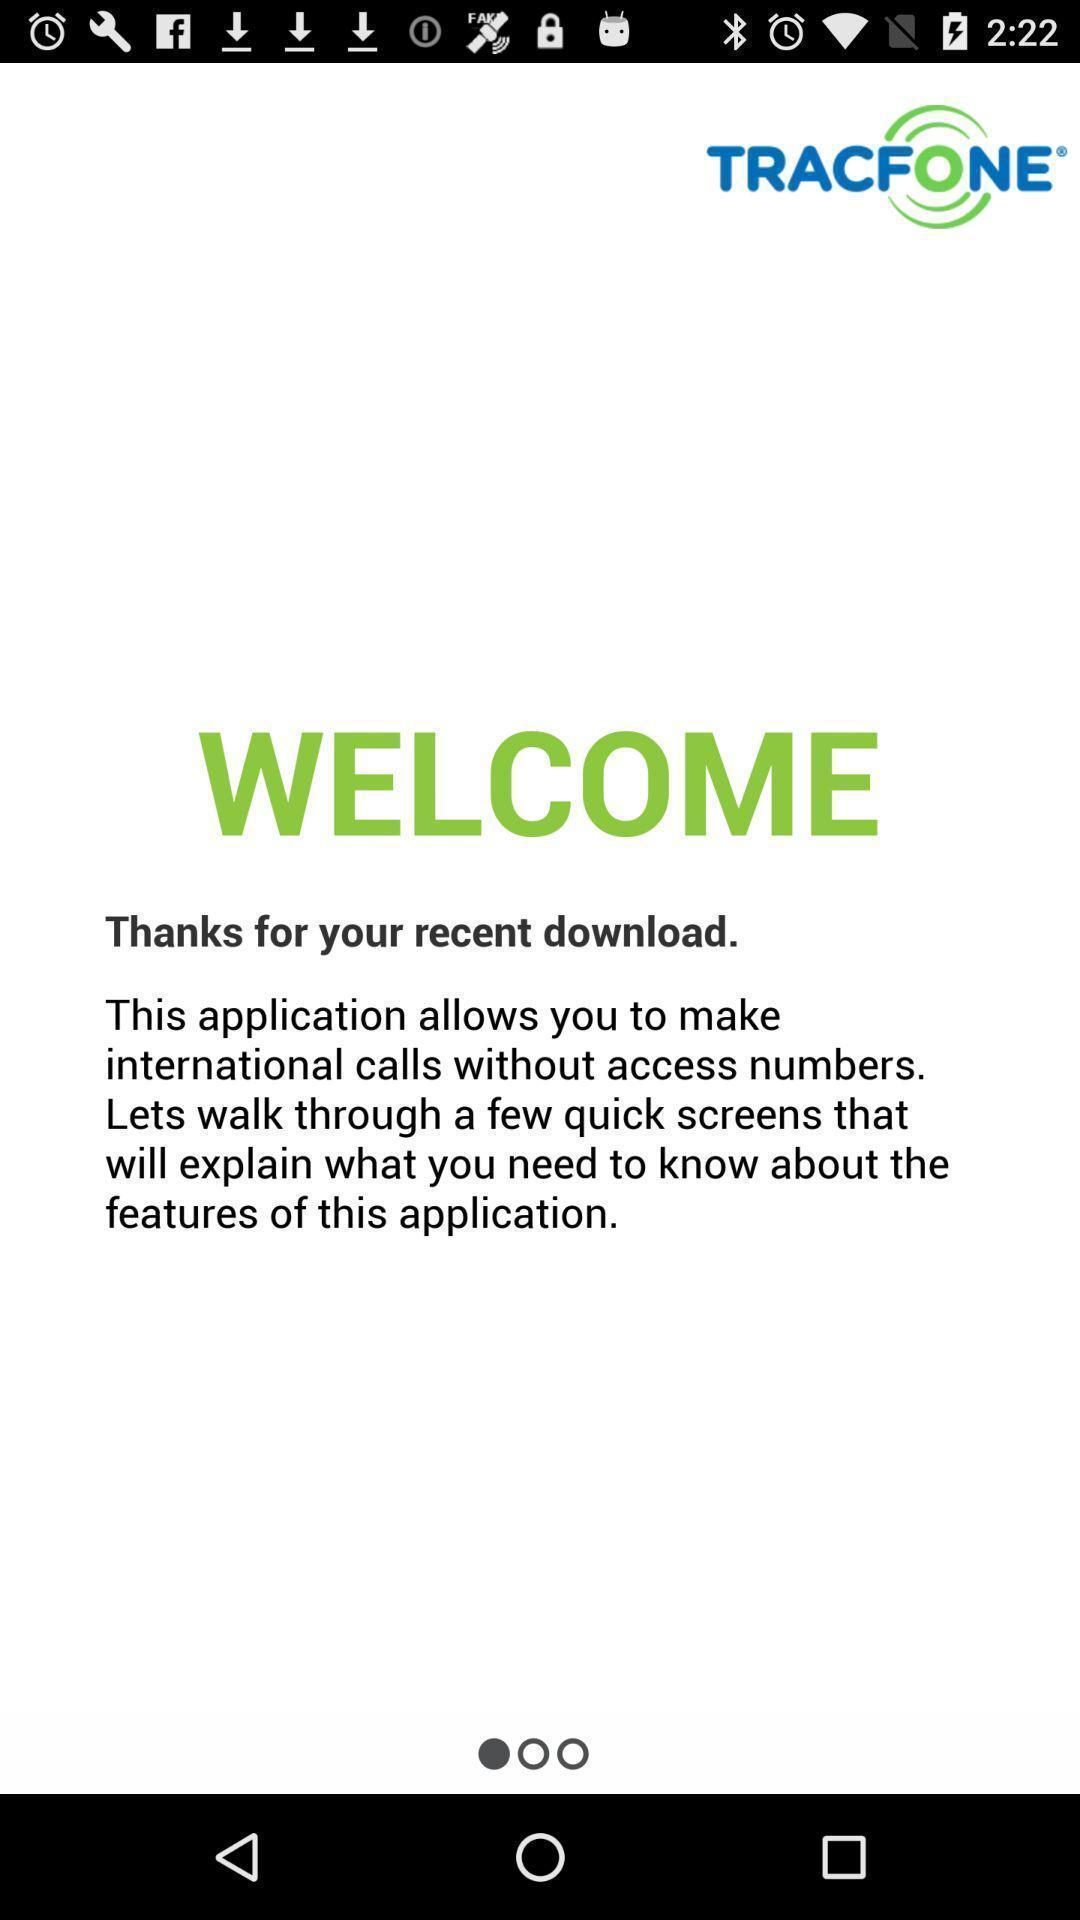What is the overall content of this screenshot? Welcoming page a tracfone an a app. 